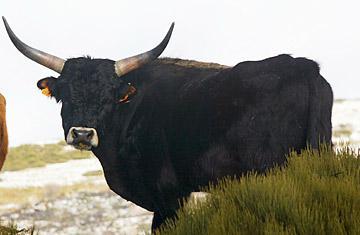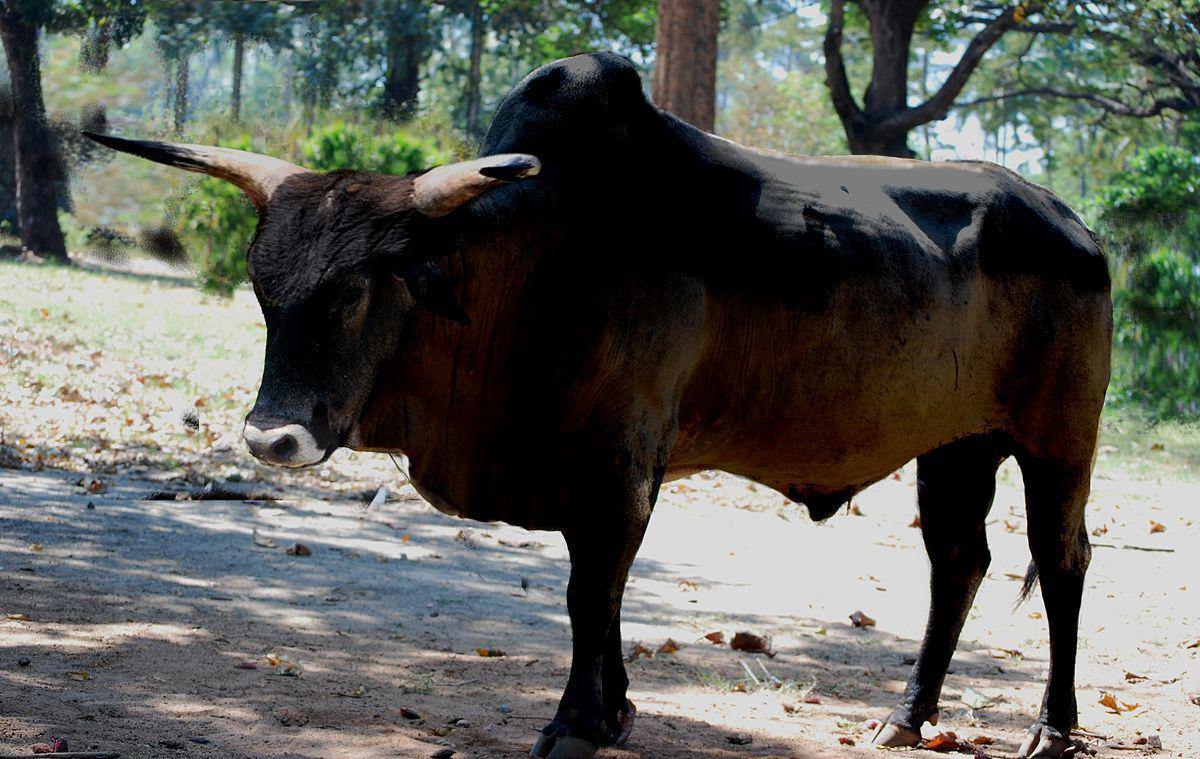The first image is the image on the left, the second image is the image on the right. Examine the images to the left and right. Is the description "One image includes at least two cattle." accurate? Answer yes or no. No. 